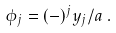<formula> <loc_0><loc_0><loc_500><loc_500>\phi _ { j } = ( - ) ^ { j } y _ { j } / a \, .</formula> 